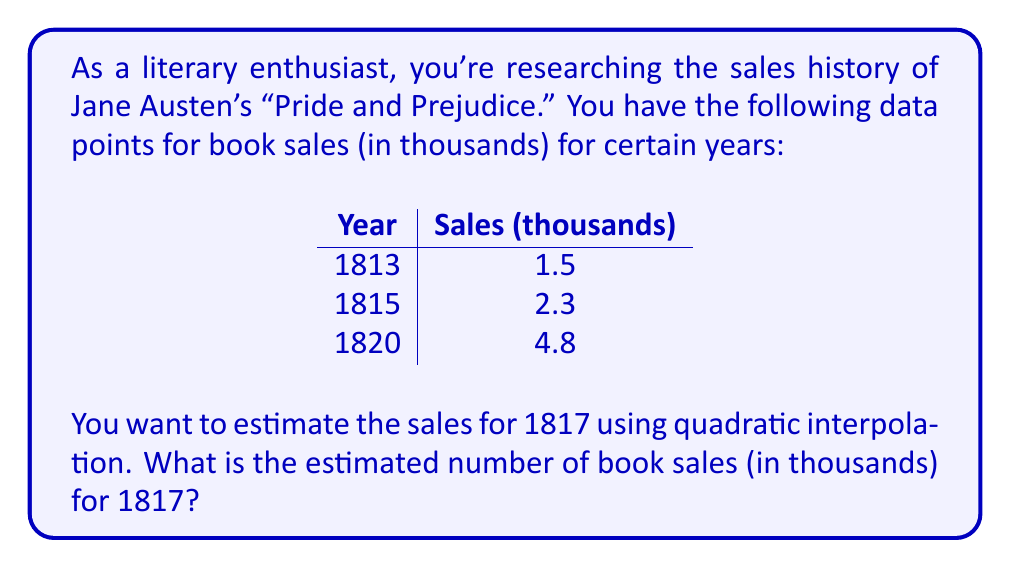Give your solution to this math problem. Let's approach this step-by-step using Lagrange interpolation:

1) We'll use the quadratic polynomial of the form:
   $$P(x) = y_1L_1(x) + y_2L_2(x) + y_3L_3(x)$$

2) Where $L_i(x)$ are Lagrange basis polynomials:
   $$L_i(x) = \prod_{j\neq i} \frac{x - x_j}{x_i - x_j}$$

3) Let's set up our data points:
   $(x_1, y_1) = (1813, 1.5)$
   $(x_2, y_2) = (1815, 2.3)$
   $(x_3, y_3) = (1820, 4.8)$

4) Now, let's calculate each $L_i(1817)$:

   $$L_1(1817) = \frac{(1817-1815)(1817-1820)}{(1813-1815)(1813-1820)} = \frac{2(-3)}{(-2)(-7)} = \frac{6}{14} = \frac{3}{7}$$
   
   $$L_2(1817) = \frac{(1817-1813)(1817-1820)}{(1815-1813)(1815-1820)} = \frac{4(-3)}{(2)(-5)} = \frac{12}{10} = \frac{6}{5}$$
   
   $$L_3(1817) = \frac{(1817-1813)(1817-1815)}{(1820-1813)(1820-1815)} = \frac{4(2)}{(7)(5)} = \frac{8}{35}$$

5) Now we can calculate $P(1817)$:
   $$P(1817) = 1.5 \cdot \frac{3}{7} + 2.3 \cdot \frac{6}{5} + 4.8 \cdot \frac{8}{35}$$

6) Simplifying:
   $$P(1817) = \frac{4.5}{7} + \frac{13.8}{5} + \frac{38.4}{35} = 0.6429 + 2.76 + 1.0971 = 3.5$$

Therefore, the estimated book sales for 1817 is 3.5 thousand.
Answer: 3.5 thousand 